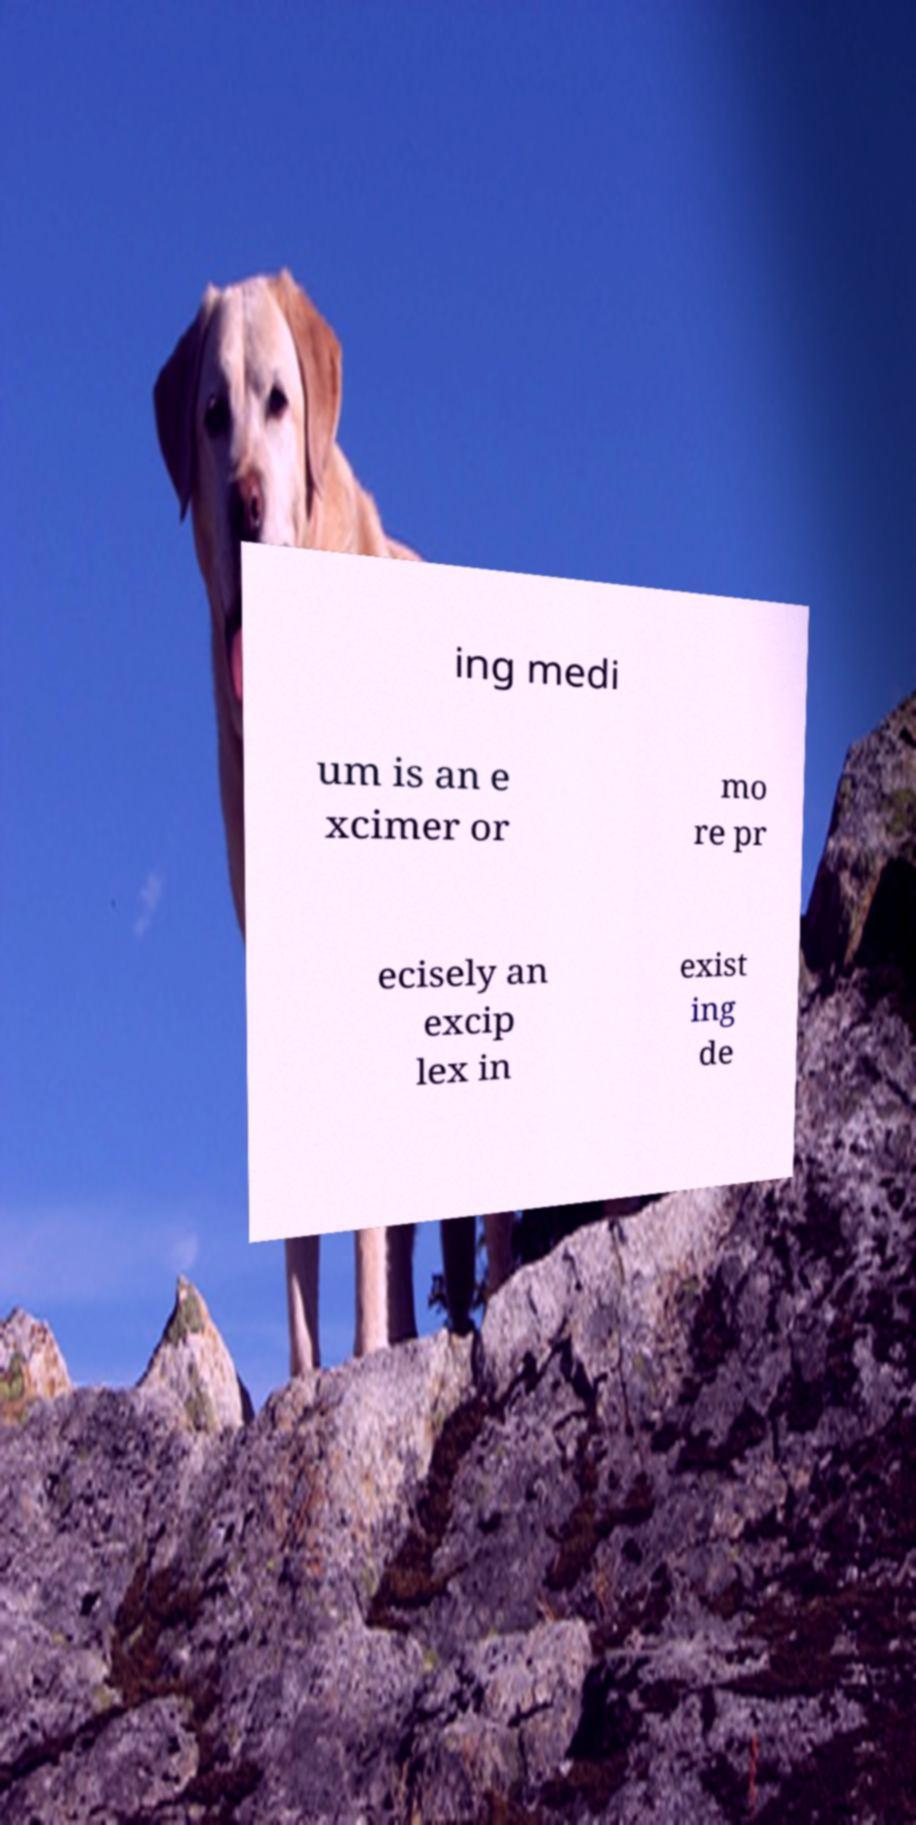For documentation purposes, I need the text within this image transcribed. Could you provide that? ing medi um is an e xcimer or mo re pr ecisely an excip lex in exist ing de 